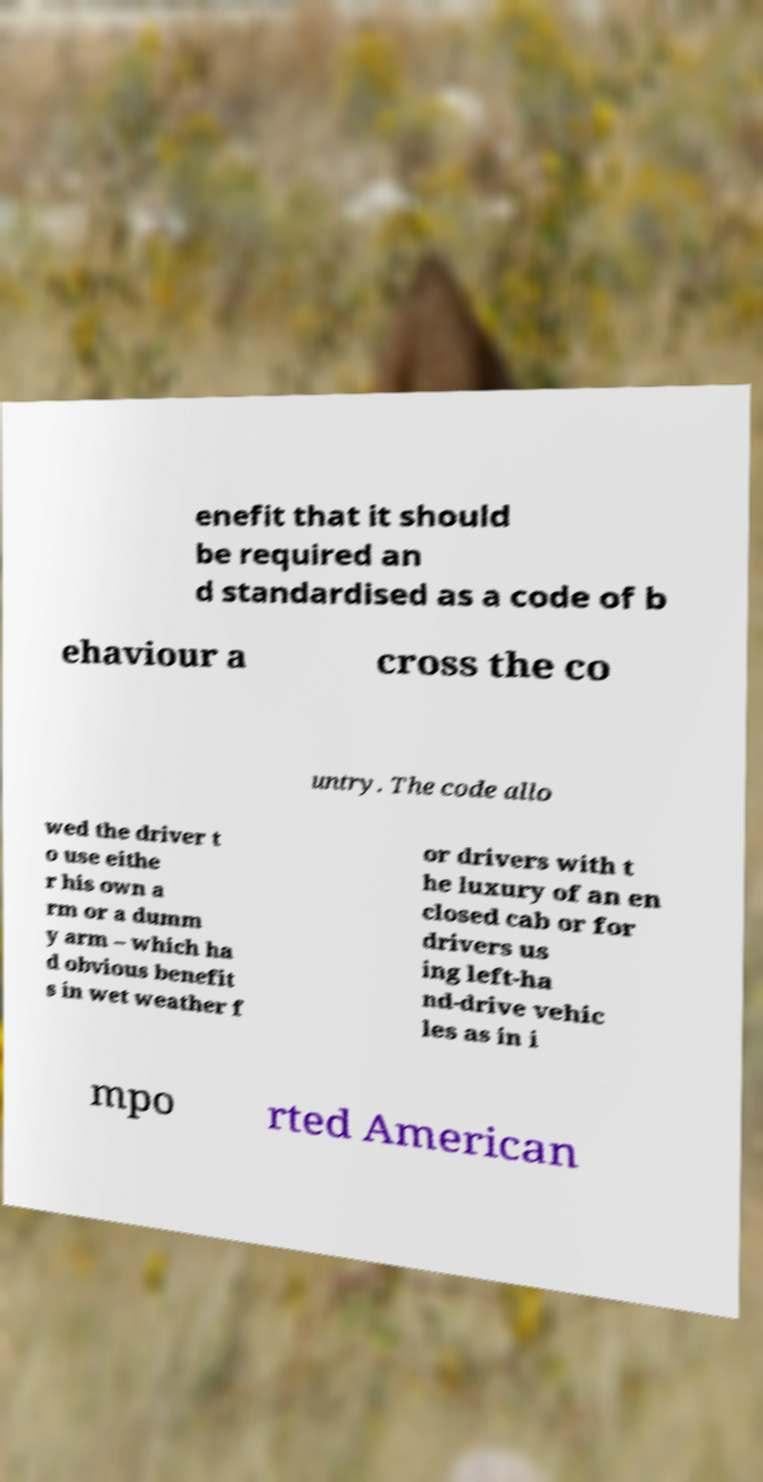There's text embedded in this image that I need extracted. Can you transcribe it verbatim? enefit that it should be required an d standardised as a code of b ehaviour a cross the co untry. The code allo wed the driver t o use eithe r his own a rm or a dumm y arm – which ha d obvious benefit s in wet weather f or drivers with t he luxury of an en closed cab or for drivers us ing left-ha nd-drive vehic les as in i mpo rted American 